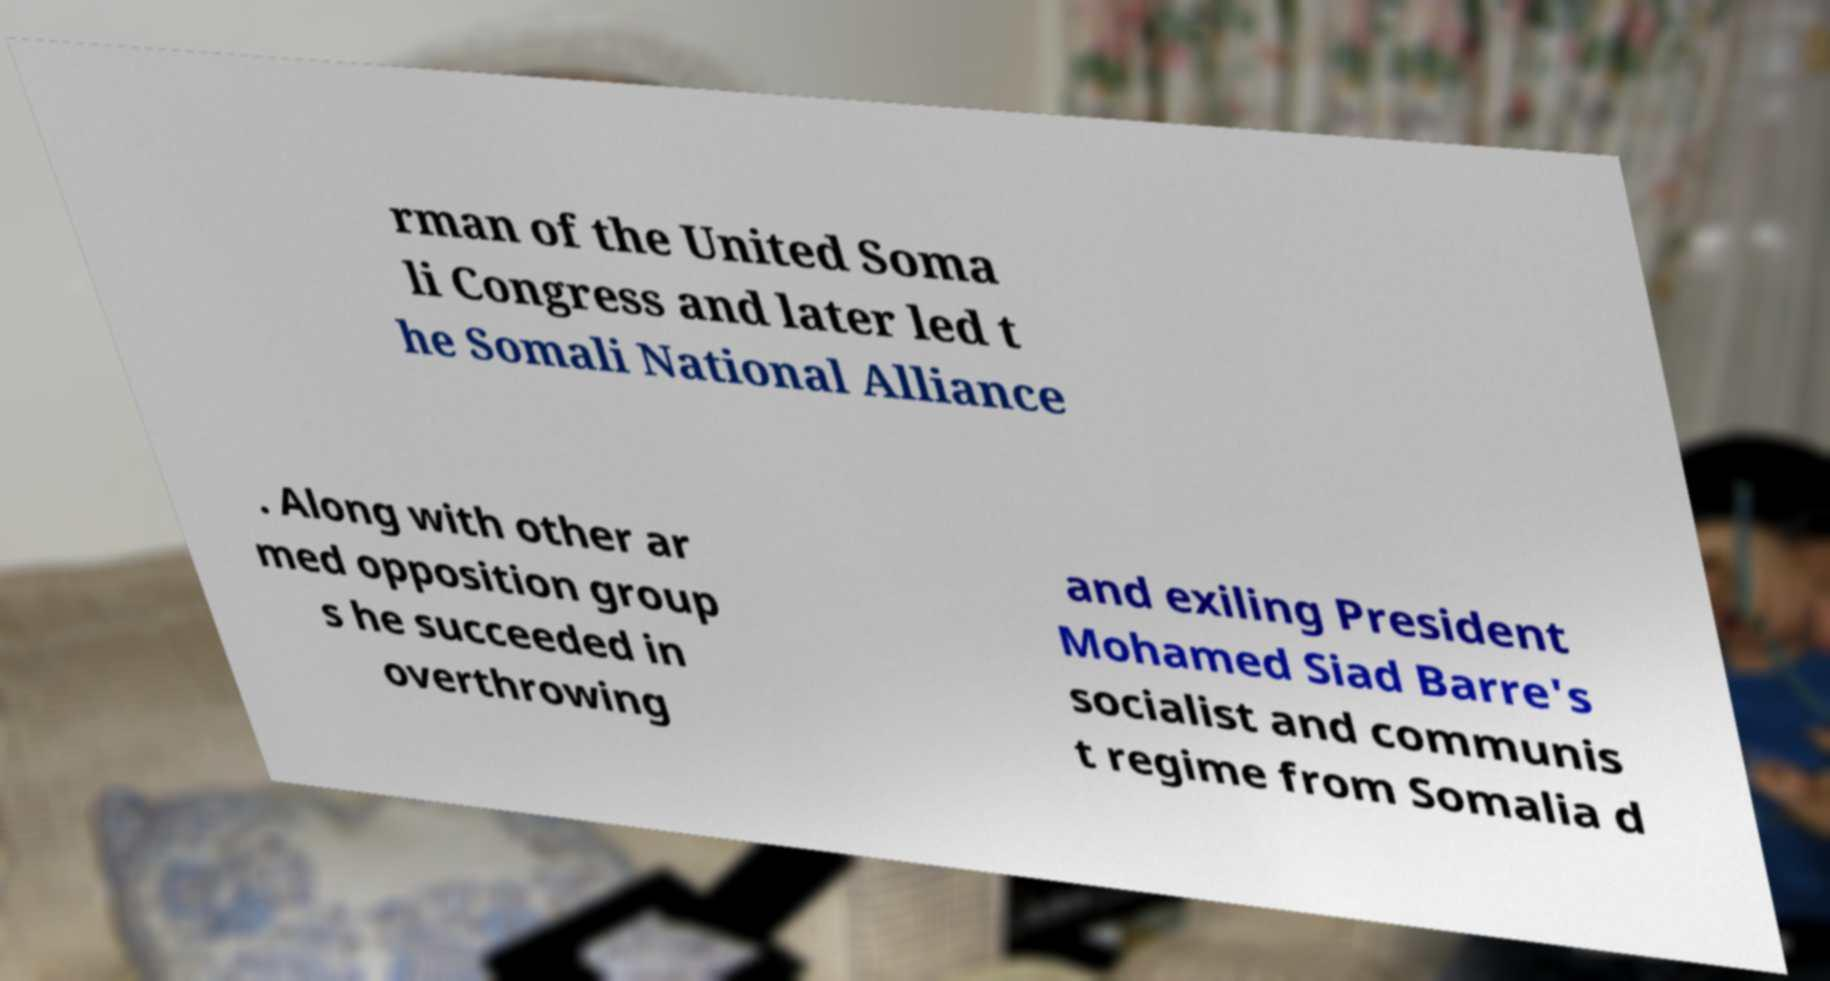There's text embedded in this image that I need extracted. Can you transcribe it verbatim? rman of the United Soma li Congress and later led t he Somali National Alliance . Along with other ar med opposition group s he succeeded in overthrowing and exiling President Mohamed Siad Barre's socialist and communis t regime from Somalia d 